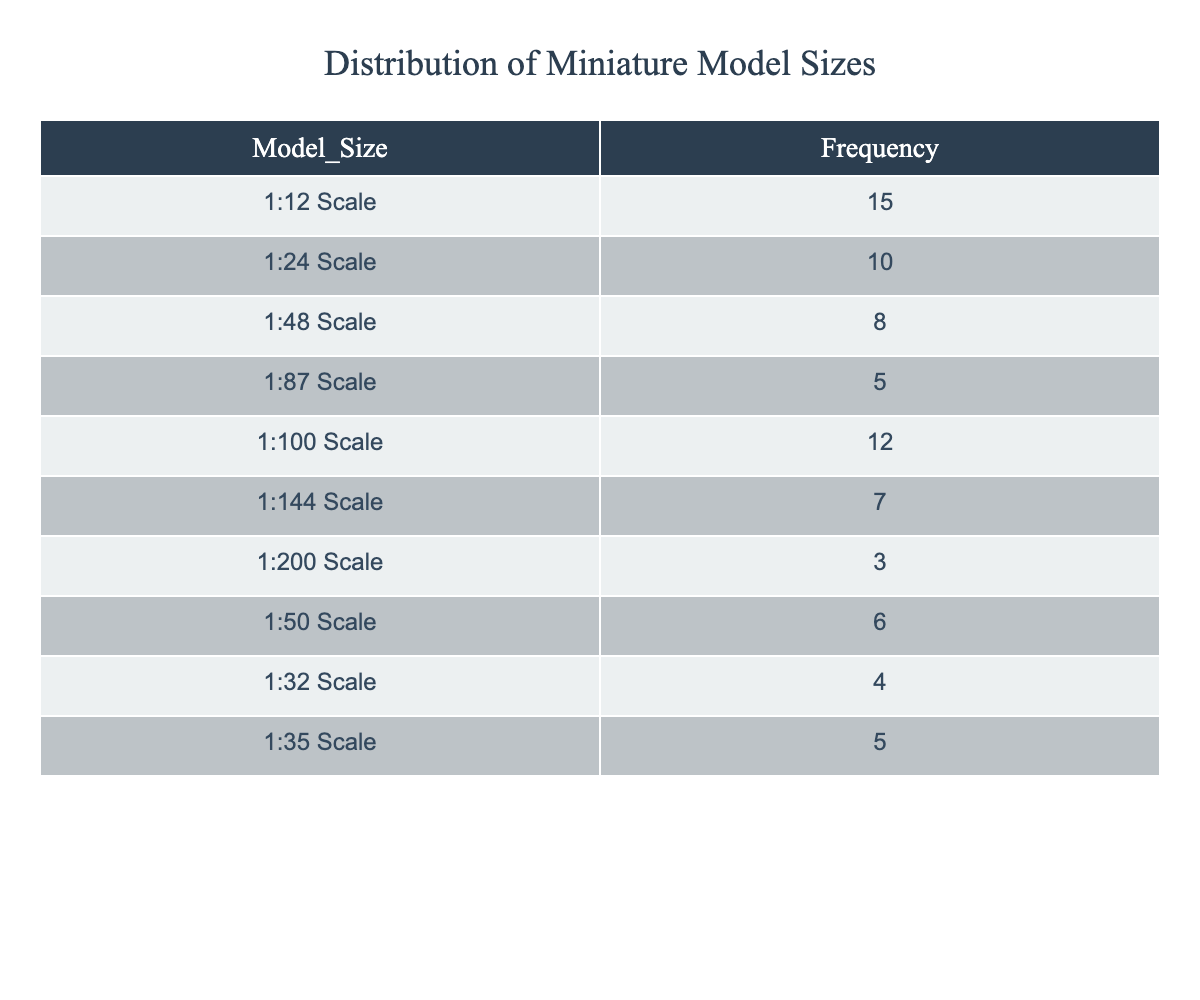What is the most preferred model size based on frequency? The table shows the frequencies of each model size. The highest frequency is 15 for the 1:12 Scale model, which is the most preferred size.
Answer: 1:12 Scale How many miniature model sizes have a frequency greater than 5? By examining the table, the model sizes with frequencies greater than 5 are 1:12 Scale (15), 1:24 Scale (10), 1:100 Scale (12), and 1:48 Scale (8). There are a total of 4 sizes that meet this criterion.
Answer: 4 What is the total frequency of all miniature model sizes? To find the total frequency, sum all frequencies: 15 + 10 + 8 + 5 + 12 + 7 + 3 + 6 + 4 + 5 = 70.
Answer: 70 Is there a miniature model size with a frequency of 1? Checking the table, there is no model size listed with a frequency of 1, as the minimum frequency recorded is 3 for the 1:200 Scale model.
Answer: No What is the average frequency of the model sizes listed in the table? To calculate the average frequency, first sum the frequencies (70, as calculated before) and then divide by the number of model sizes (10). Thus, the average is 70/10 = 7.
Answer: 7 Which model size has the least frequency, and what is its value? By scanning the frequency values, the least frequent model size is the 1:200 Scale with a frequency of 3.
Answer: 1:200 Scale, 3 How many more miniature models are there in the 1:12 Scale compared to the 1:200 Scale? The 1:12 Scale has a frequency of 15, while the 1:200 Scale has a frequency of 3. The difference between them is 15 - 3 = 12.
Answer: 12 What percentage of the total frequency does the 1:48 Scale represent? The frequency for the 1:48 Scale is 8, and the total frequency is 70. To find the percentage, calculate (8/70) * 100, which is approximately 11.43%.
Answer: Approximately 11.43% How many model sizes have frequencies below or equal to 5? By reviewing the table, the model sizes with frequencies of 5 or below are 1:87 Scale (5), 1:200 Scale (3), 1:50 Scale (6, not included), 1:32 Scale (4), and 1:35 Scale (5). Thus, only 3 sizes fall below or are equal to 5.
Answer: 3 